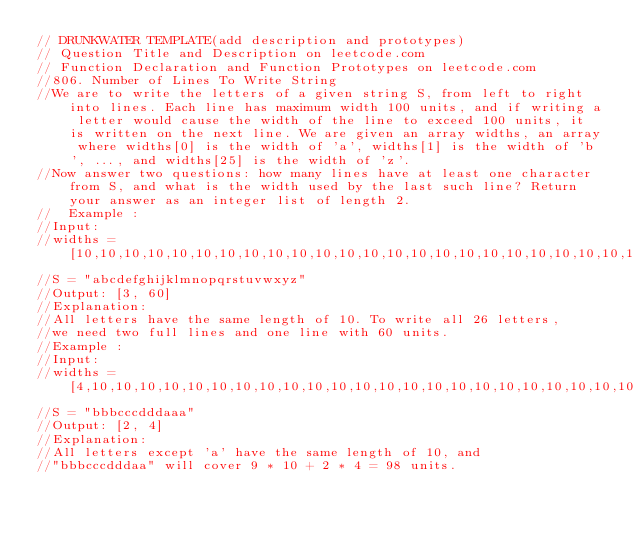Convert code to text. <code><loc_0><loc_0><loc_500><loc_500><_Kotlin_>// DRUNKWATER TEMPLATE(add description and prototypes)
// Question Title and Description on leetcode.com
// Function Declaration and Function Prototypes on leetcode.com
//806. Number of Lines To Write String
//We are to write the letters of a given string S, from left to right into lines. Each line has maximum width 100 units, and if writing a letter would cause the width of the line to exceed 100 units, it is written on the next line. We are given an array widths, an array where widths[0] is the width of 'a', widths[1] is the width of 'b', ..., and widths[25] is the width of 'z'.
//Now answer two questions: how many lines have at least one character from S, and what is the width used by the last such line? Return your answer as an integer list of length 2.
//  Example :
//Input: 
//widths = [10,10,10,10,10,10,10,10,10,10,10,10,10,10,10,10,10,10,10,10,10,10,10,10,10,10]
//S = "abcdefghijklmnopqrstuvwxyz"
//Output: [3, 60]
//Explanation: 
//All letters have the same length of 10. To write all 26 letters,
//we need two full lines and one line with 60 units.
//Example :
//Input: 
//widths = [4,10,10,10,10,10,10,10,10,10,10,10,10,10,10,10,10,10,10,10,10,10,10,10,10,10]
//S = "bbbcccdddaaa"
//Output: [2, 4]
//Explanation: 
//All letters except 'a' have the same length of 10, and 
//"bbbcccdddaa" will cover 9 * 10 + 2 * 4 = 98 units.</code> 